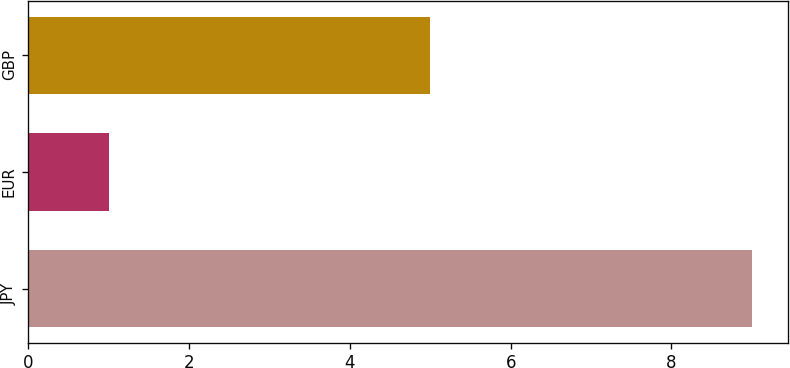Convert chart to OTSL. <chart><loc_0><loc_0><loc_500><loc_500><bar_chart><fcel>JPY<fcel>EUR<fcel>GBP<nl><fcel>9<fcel>1<fcel>5<nl></chart> 